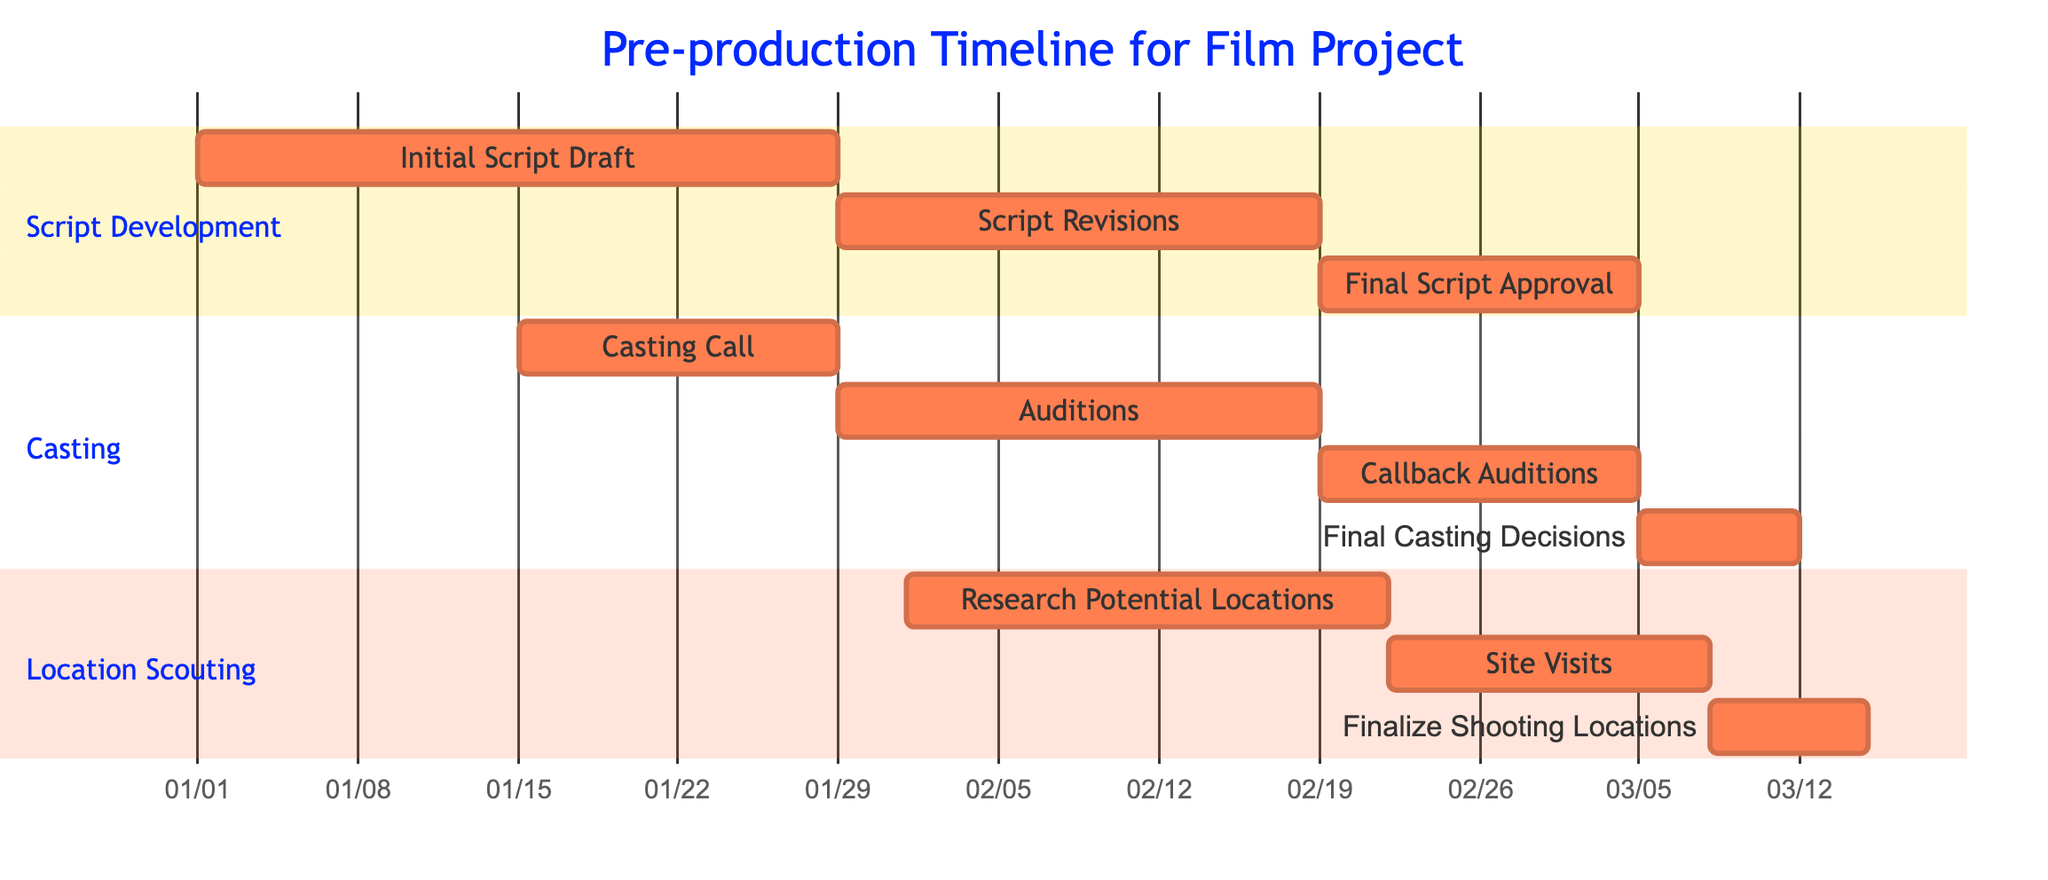What is the duration of the Initial Script Draft? The diagram shows that the "Initial Script Draft" task is marked with a duration of "4 weeks." This information is directly indicated in the section for Script Development.
Answer: 4 weeks How long does the entire Casting process take? To find the total duration for Casting, we need to sum the individual durations of each task: Casting Call (2 weeks) + Auditions (3 weeks) + Callback Auditions (2 weeks) + Final Casting Decisions (1 week) = 8 weeks total for Casting.
Answer: 8 weeks Which task starts first in Location Scouting? Analyzing the Location Scouting section, the first task listed is "Research Potential Locations," which indicates that it starts first in this section.
Answer: Research Potential Locations What task follows Script Revisions? The flow of tasks in the Script Development section shows that "Final Script Approval" follows immediately after "Script Revisions," making this the next task.
Answer: Final Script Approval How many weeks does it take to finalize shooting locations? The "Finalize Shooting Locations" task has a duration of "1 week," which indicates the time needed to complete this task.
Answer: 1 week Which task has the longest duration in pre-production? By reviewing each section and their tasks, "Script Development" is divided into three tasks: Initial Script Draft (4 weeks), Script Revisions (3 weeks), and Final Script Approval (2 weeks). The longest single task overall is "Initial Script Draft" at 4 weeks.
Answer: Initial Script Draft What is the total duration of the entire pre-production phase? We calculate the total duration by adding the longest duration of tasks consecutively in the sections: Script Development (4+3+2 weeks = 9 weeks), Casting (2+3+2+1 weeks = 8 weeks), and Location Scouting (3+2+1 weeks = 6 weeks). The pre-production phase has overlapping schedules, so it takes the maximum sequential grouping. Total is 9 weeks.
Answer: 9 weeks How many subtasks are under the Casting section? There are four subtasks listed in the Casting section: Casting Call, Auditions, Callback Auditions, and Final Casting Decisions. Therefore, the total number of subtasks is four.
Answer: 4 subtasks Which task directly follows Auditions? According to the flow in Casting, the task that succeeds Auditions is "Callback Auditions." This is shown directly after Auditions in the Gantt chart's structure.
Answer: Callback Auditions 